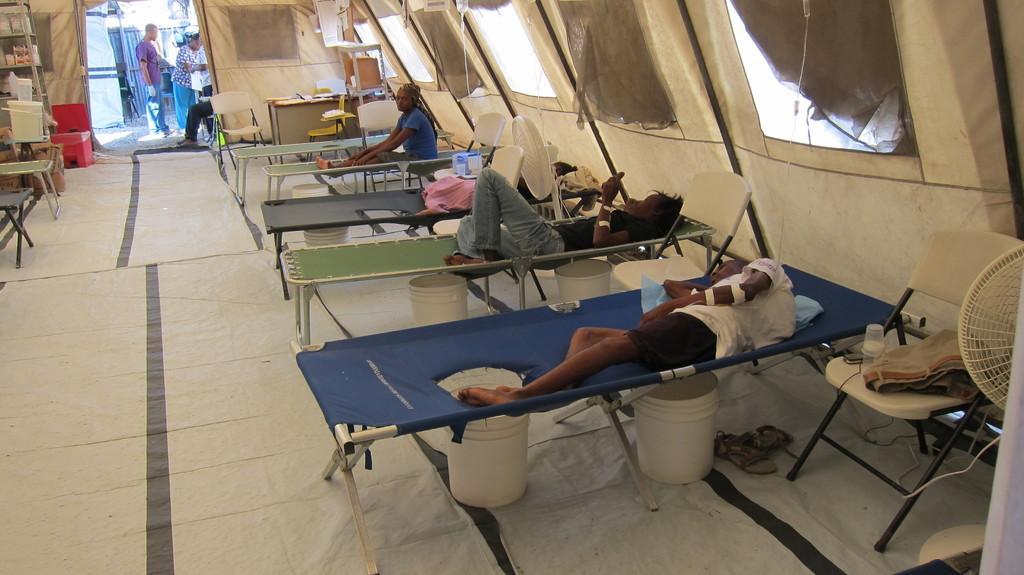Could you give a brief overview of what you see in this image? This is an image clicked inside the tent. Here I can see few people are lying on the cot. On the outside of this text there are few people standing. On the right side of this image there is a chair. 